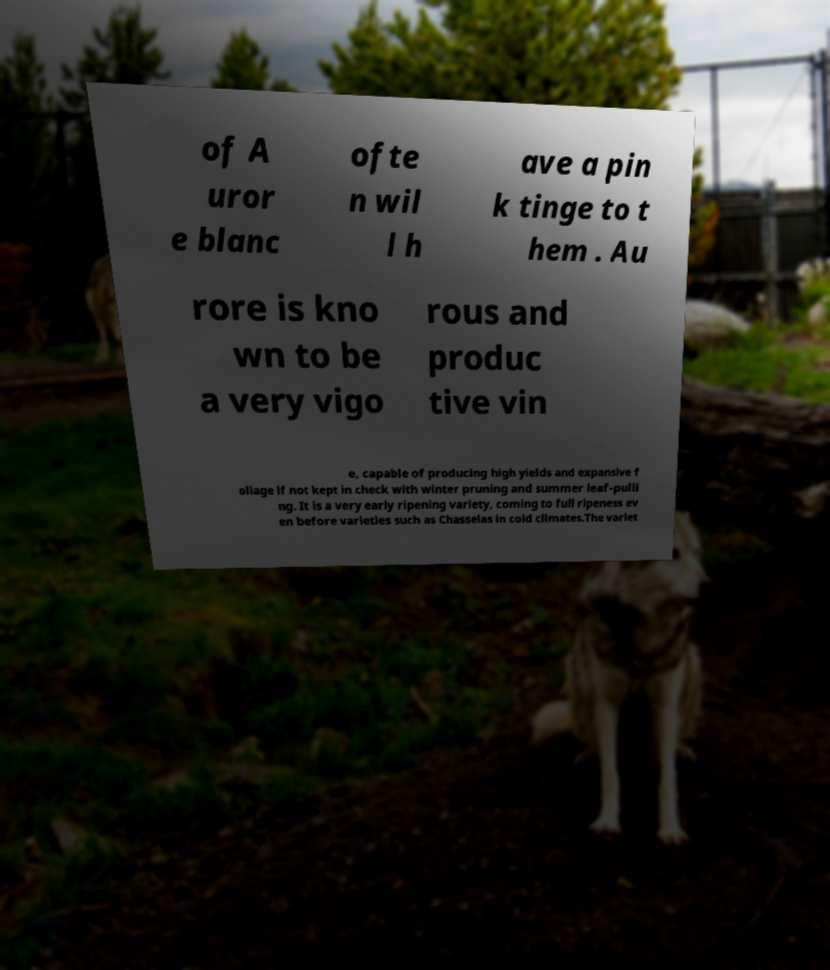I need the written content from this picture converted into text. Can you do that? of A uror e blanc ofte n wil l h ave a pin k tinge to t hem . Au rore is kno wn to be a very vigo rous and produc tive vin e, capable of producing high yields and expansive f oliage if not kept in check with winter pruning and summer leaf-pulli ng. It is a very early ripening variety, coming to full ripeness ev en before varieties such as Chasselas in cold climates.The variet 